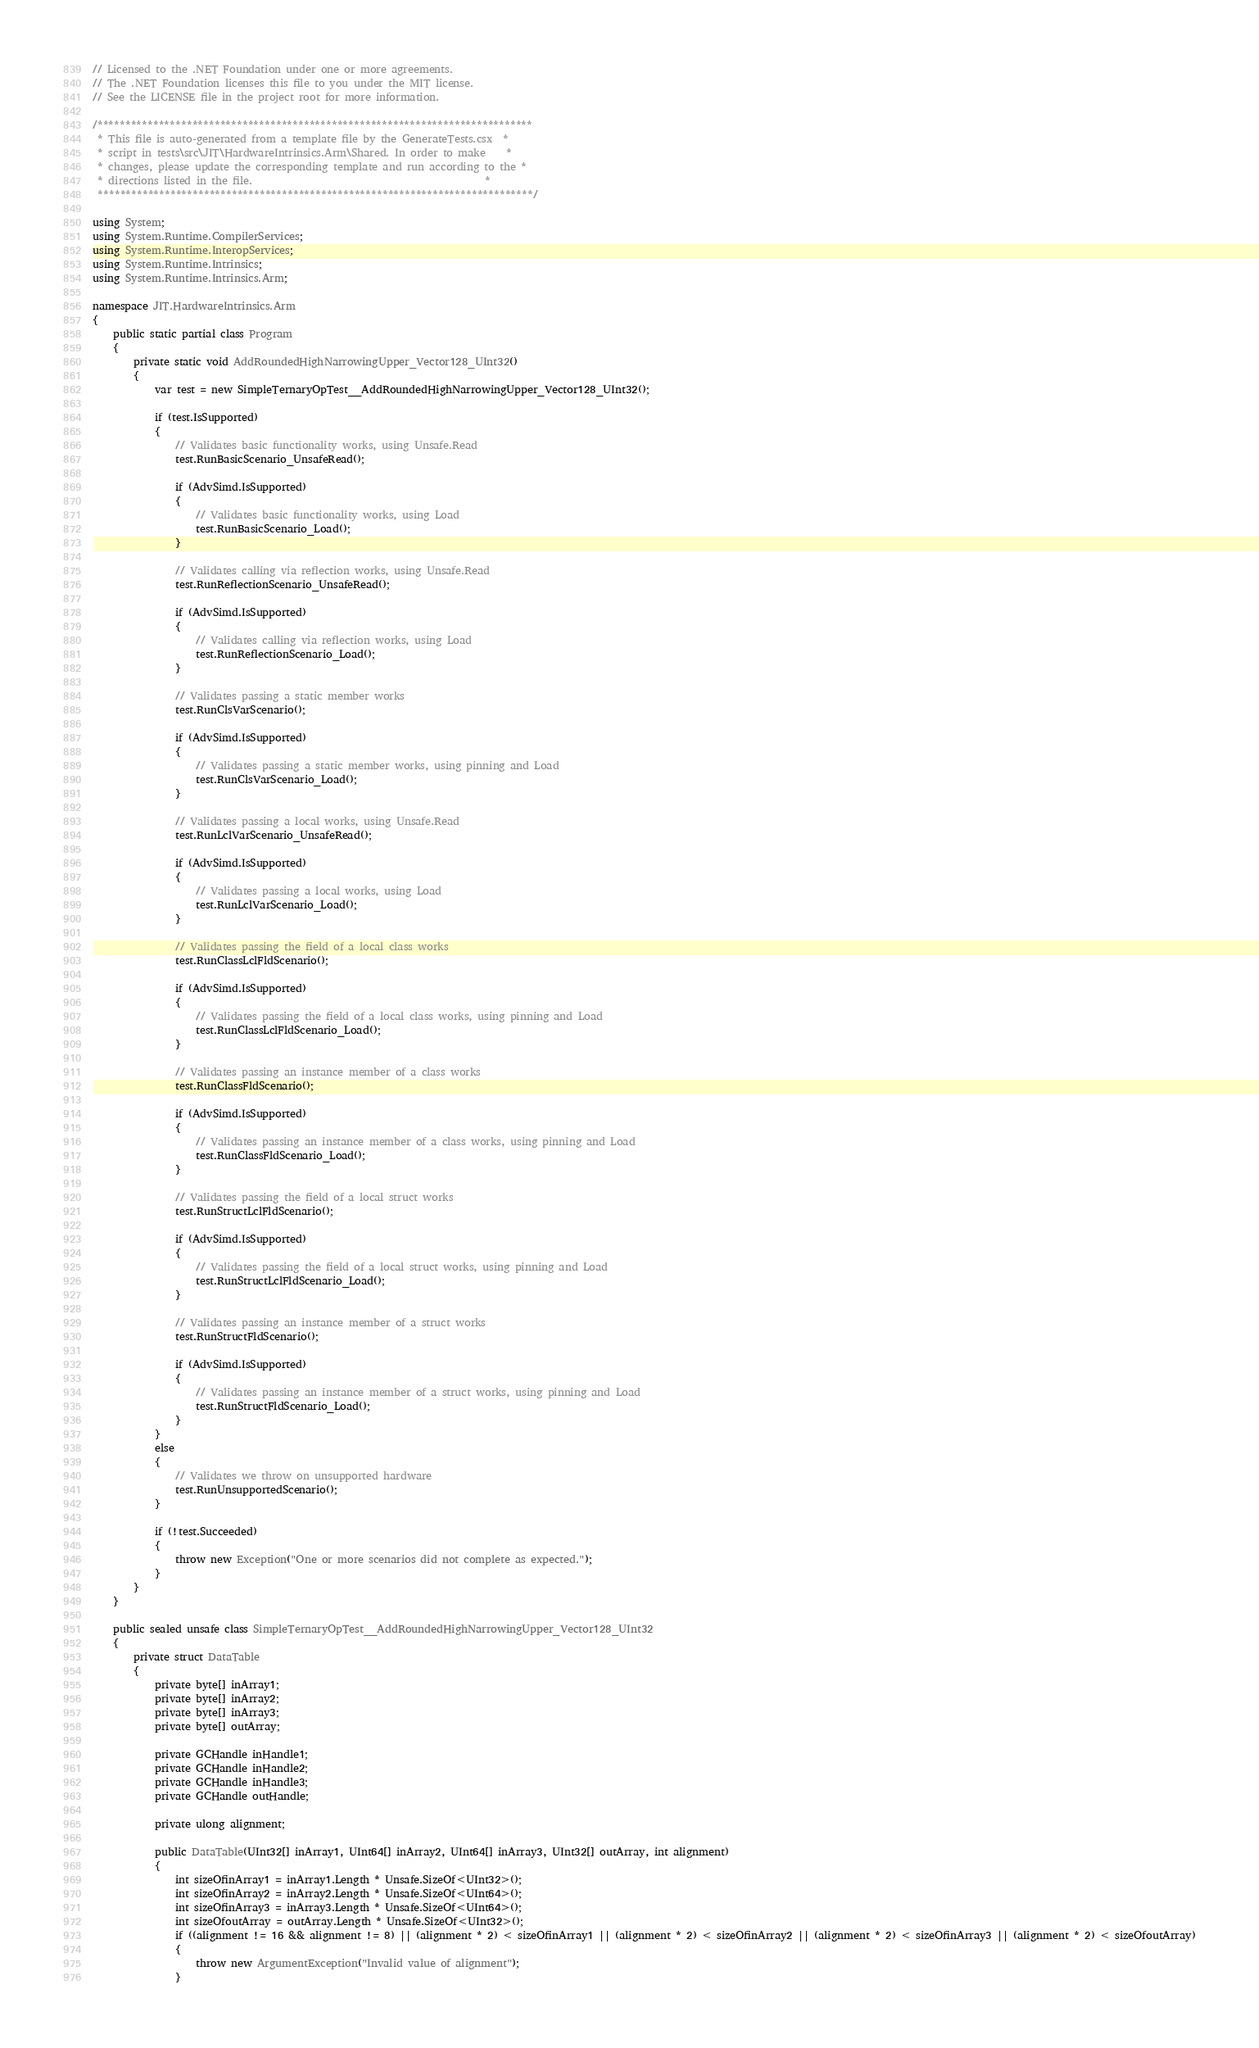Convert code to text. <code><loc_0><loc_0><loc_500><loc_500><_C#_>// Licensed to the .NET Foundation under one or more agreements.
// The .NET Foundation licenses this file to you under the MIT license.
// See the LICENSE file in the project root for more information.

/******************************************************************************
 * This file is auto-generated from a template file by the GenerateTests.csx  *
 * script in tests\src\JIT\HardwareIntrinsics.Arm\Shared. In order to make    *
 * changes, please update the corresponding template and run according to the *
 * directions listed in the file.                                             *
 ******************************************************************************/

using System;
using System.Runtime.CompilerServices;
using System.Runtime.InteropServices;
using System.Runtime.Intrinsics;
using System.Runtime.Intrinsics.Arm;

namespace JIT.HardwareIntrinsics.Arm
{
    public static partial class Program
    {
        private static void AddRoundedHighNarrowingUpper_Vector128_UInt32()
        {
            var test = new SimpleTernaryOpTest__AddRoundedHighNarrowingUpper_Vector128_UInt32();

            if (test.IsSupported)
            {
                // Validates basic functionality works, using Unsafe.Read
                test.RunBasicScenario_UnsafeRead();

                if (AdvSimd.IsSupported)
                {
                    // Validates basic functionality works, using Load
                    test.RunBasicScenario_Load();
                }

                // Validates calling via reflection works, using Unsafe.Read
                test.RunReflectionScenario_UnsafeRead();

                if (AdvSimd.IsSupported)
                {
                    // Validates calling via reflection works, using Load
                    test.RunReflectionScenario_Load();
                }

                // Validates passing a static member works
                test.RunClsVarScenario();

                if (AdvSimd.IsSupported)
                {
                    // Validates passing a static member works, using pinning and Load
                    test.RunClsVarScenario_Load();
                }

                // Validates passing a local works, using Unsafe.Read
                test.RunLclVarScenario_UnsafeRead();

                if (AdvSimd.IsSupported)
                {
                    // Validates passing a local works, using Load
                    test.RunLclVarScenario_Load();
                }

                // Validates passing the field of a local class works
                test.RunClassLclFldScenario();

                if (AdvSimd.IsSupported)
                {
                    // Validates passing the field of a local class works, using pinning and Load
                    test.RunClassLclFldScenario_Load();
                }

                // Validates passing an instance member of a class works
                test.RunClassFldScenario();

                if (AdvSimd.IsSupported)
                {
                    // Validates passing an instance member of a class works, using pinning and Load
                    test.RunClassFldScenario_Load();
                }

                // Validates passing the field of a local struct works
                test.RunStructLclFldScenario();

                if (AdvSimd.IsSupported)
                {
                    // Validates passing the field of a local struct works, using pinning and Load
                    test.RunStructLclFldScenario_Load();
                }

                // Validates passing an instance member of a struct works
                test.RunStructFldScenario();

                if (AdvSimd.IsSupported)
                {
                    // Validates passing an instance member of a struct works, using pinning and Load
                    test.RunStructFldScenario_Load();
                }
            }
            else
            {
                // Validates we throw on unsupported hardware
                test.RunUnsupportedScenario();
            }

            if (!test.Succeeded)
            {
                throw new Exception("One or more scenarios did not complete as expected.");
            }
        }
    }

    public sealed unsafe class SimpleTernaryOpTest__AddRoundedHighNarrowingUpper_Vector128_UInt32
    {
        private struct DataTable
        {
            private byte[] inArray1;
            private byte[] inArray2;
            private byte[] inArray3;
            private byte[] outArray;

            private GCHandle inHandle1;
            private GCHandle inHandle2;
            private GCHandle inHandle3;
            private GCHandle outHandle;

            private ulong alignment;

            public DataTable(UInt32[] inArray1, UInt64[] inArray2, UInt64[] inArray3, UInt32[] outArray, int alignment)
            {
                int sizeOfinArray1 = inArray1.Length * Unsafe.SizeOf<UInt32>();
                int sizeOfinArray2 = inArray2.Length * Unsafe.SizeOf<UInt64>();
                int sizeOfinArray3 = inArray3.Length * Unsafe.SizeOf<UInt64>();
                int sizeOfoutArray = outArray.Length * Unsafe.SizeOf<UInt32>();
                if ((alignment != 16 && alignment != 8) || (alignment * 2) < sizeOfinArray1 || (alignment * 2) < sizeOfinArray2 || (alignment * 2) < sizeOfinArray3 || (alignment * 2) < sizeOfoutArray)
                {
                    throw new ArgumentException("Invalid value of alignment");
                }
</code> 